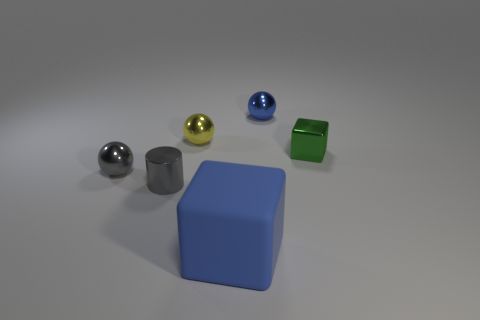What number of balls have the same color as the rubber object?
Offer a terse response. 1. What is the color of the other thing that is the same shape as the large object?
Keep it short and to the point. Green. How many tiny yellow spheres are in front of the cube in front of the tiny shiny cube?
Offer a very short reply. 0. What number of blocks are either small objects or tiny gray objects?
Provide a succinct answer. 1. Are any purple metal blocks visible?
Give a very brief answer. No. What size is the blue rubber object that is the same shape as the tiny green object?
Your answer should be compact. Large. There is a tiny shiny thing that is on the right side of the blue object that is behind the large rubber thing; what is its shape?
Offer a terse response. Cube. What number of brown things are either rubber blocks or metal balls?
Provide a short and direct response. 0. What color is the cylinder?
Your answer should be compact. Gray. Do the matte object and the shiny block have the same size?
Ensure brevity in your answer.  No. 